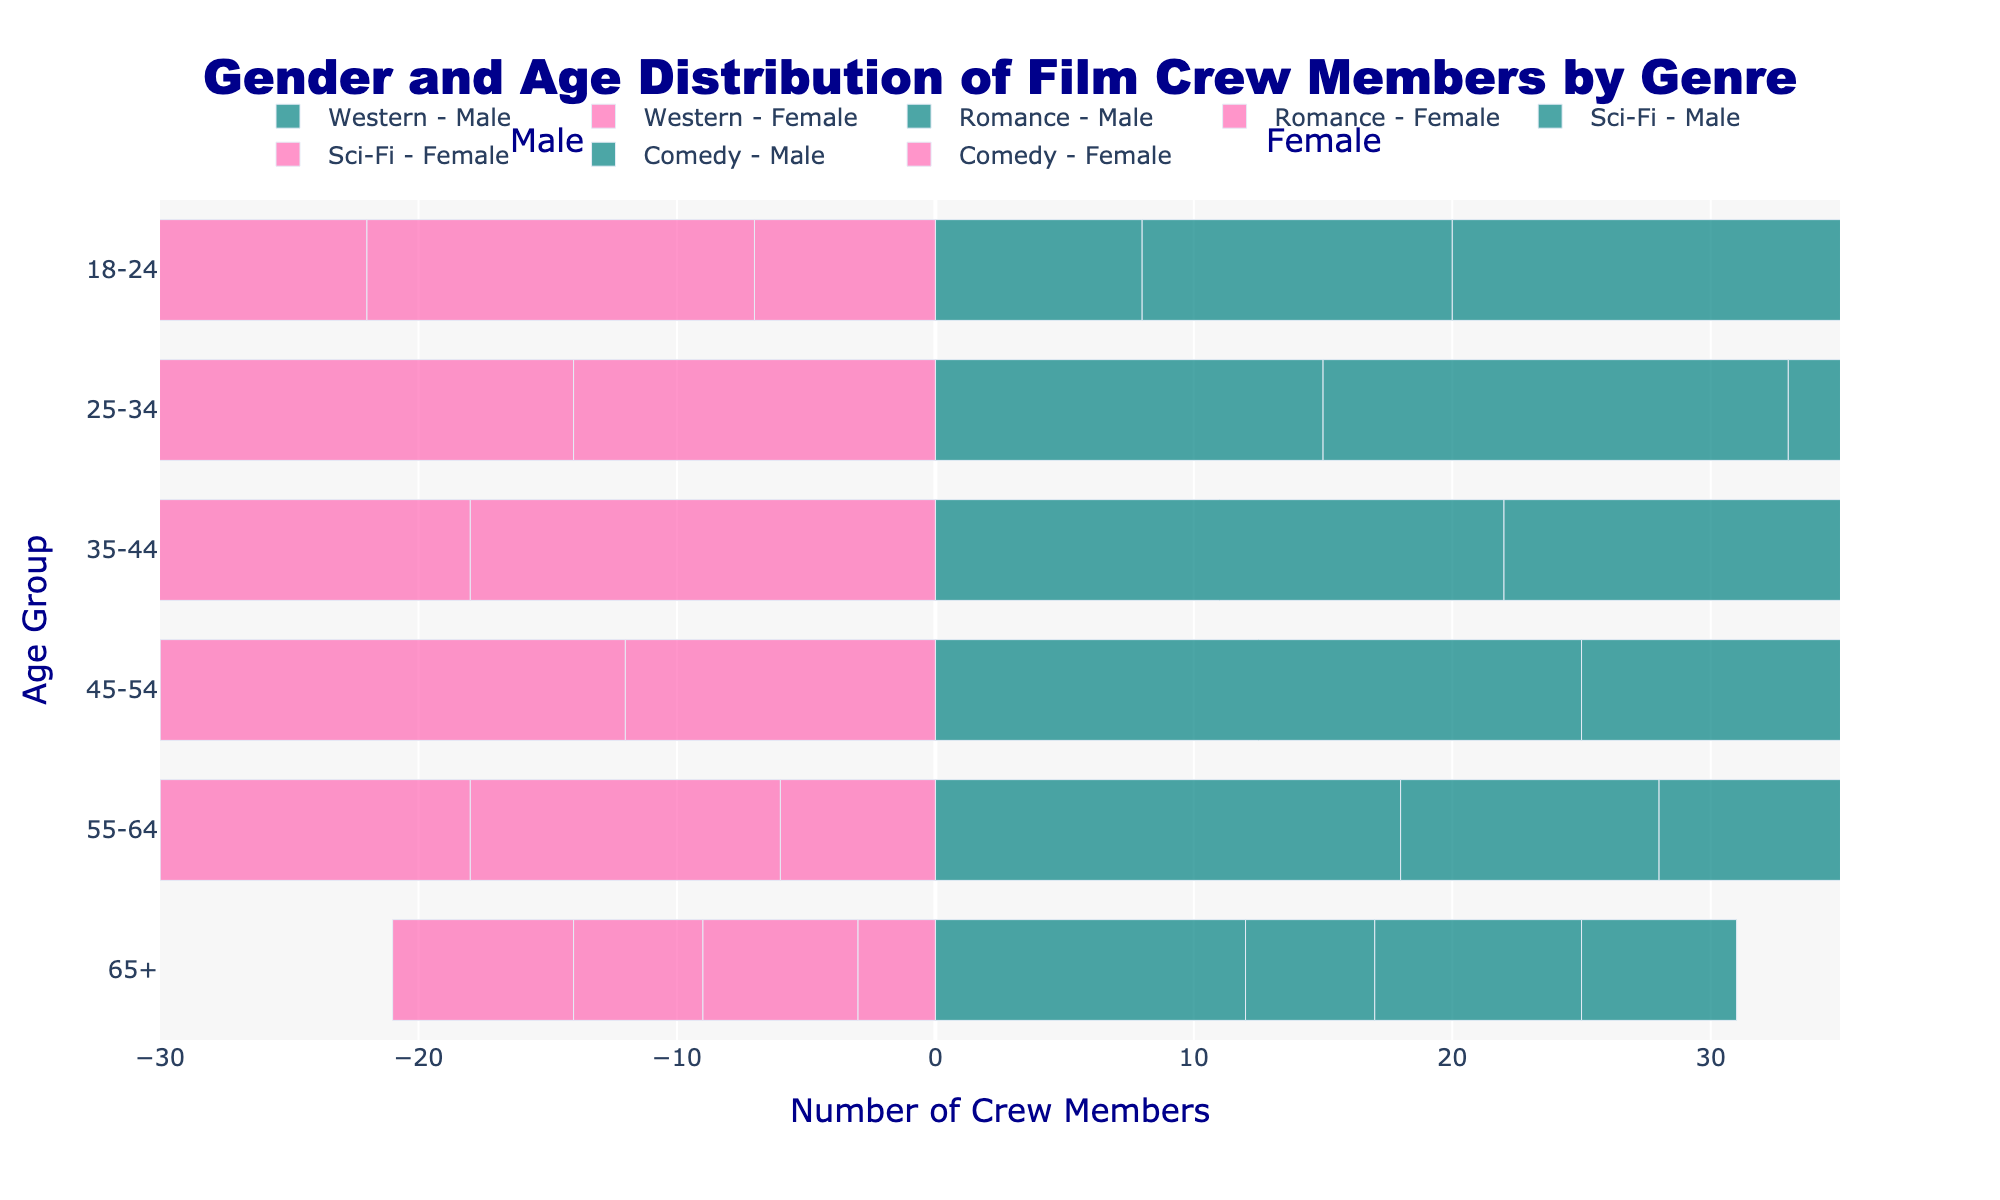What's the title shown on the figure? The title is prominently displayed at the top center of the figure. It summarizes the visualized data with "Gender and Age Distribution of Film Crew Members by Genre".
Answer: Gender and Age Distribution of Film Crew Members by Genre What two colors are used to represent male and female crew members? The bar representing male crew members is colored in teal, while the bar for female crew members is colored in pink. These colors help to easily differentiate between genders.
Answer: teal and pink Which age group has the highest number of male crew members in the Western genre? Look for the longest teal bar within the Western genre, which corresponds to the number of male crew members. The age group 45-54 has the highest number of male crew members.
Answer: 45-54 How many female crew members are there between the ages of 25-34 in the Romance genre? Find the pink bar for the age group 25-34 in the Romance genre. The value indicated is -22, but since it’s counting people, we take the absolute value.
Answer: 22 Compare the number of male crew members aged 35-44 in the Sci-Fi genre to those in the Comedy genre. Which genre has more? Locate the bars representing males aged 35-44 in both Sci-Fi and Comedy genres. The Sci-Fi bar is longer than the Comedy bar, indicating more male crew members in the Sci-Fi genre.
Answer: Sci-Fi What is the total number of crew members aged 45-54 in the Comedy genre? Sum the absolute values of both the male and female bars for ages 45-54 in the Comedy genre. Male is 20 and Female is 22, so the total is 20 + 22.
Answer: 42 Which genre has the smallest number of female crew members aged 65+? Identify the shortest pink bar among the 65+ age group across all genres. The Western genre has the smallest value for female crew members.
Answer: Western For the age group 18-24, which genre has a higher percentage of female crew members compared to total crew members of that group? Compare the pink bars for age group 18-24 across all genres to see which one has relatively larger proportions. Romance has more female crew members compared to the total.
Answer: Romance How does the distribution of male crew members aged 55-64 compare between the Western and Sci-Fi genres? Compare the lengths of the teal bars for the age group 55-64 in both genres. The Western genre has a longer bar compared to Sci-Fi, indicating more male crew members.
Answer: Western What is the total number of female crew members in the age group 35-44 across all genres combined? Add the absolute values of the female bars for age group 35-44 across all genres: Western (18), Romance (25), Sci-Fi (28), and Comedy (28). So, the total is 18 + 25 + 28 + 28.
Answer: 99 